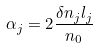<formula> <loc_0><loc_0><loc_500><loc_500>\alpha _ { j } = 2 \frac { \delta n _ { j } l _ { j } } { n _ { 0 } }</formula> 